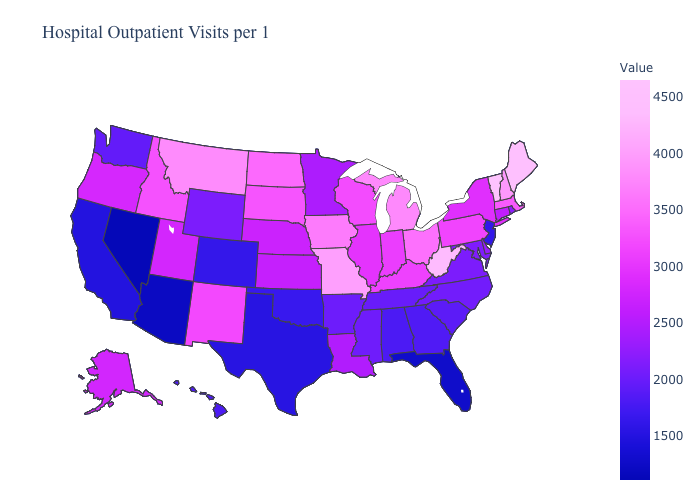Which states have the lowest value in the MidWest?
Be succinct. Minnesota. Among the states that border South Dakota , does Nebraska have the lowest value?
Concise answer only. No. Does Texas have the lowest value in the South?
Answer briefly. No. Among the states that border Indiana , which have the lowest value?
Write a very short answer. Illinois. 